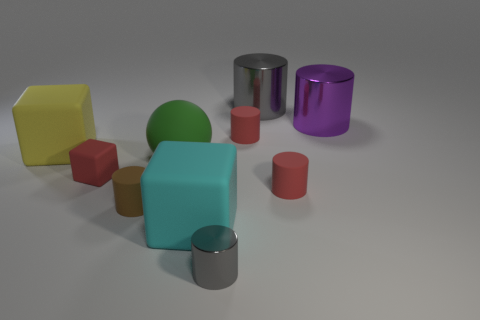Subtract all red cylinders. How many cylinders are left? 4 Subtract all large cylinders. How many cylinders are left? 4 Subtract all yellow cylinders. Subtract all red spheres. How many cylinders are left? 6 Subtract all spheres. How many objects are left? 9 Subtract 0 cyan cylinders. How many objects are left? 10 Subtract all red blocks. Subtract all tiny brown cylinders. How many objects are left? 8 Add 6 large purple metallic cylinders. How many large purple metallic cylinders are left? 7 Add 4 cylinders. How many cylinders exist? 10 